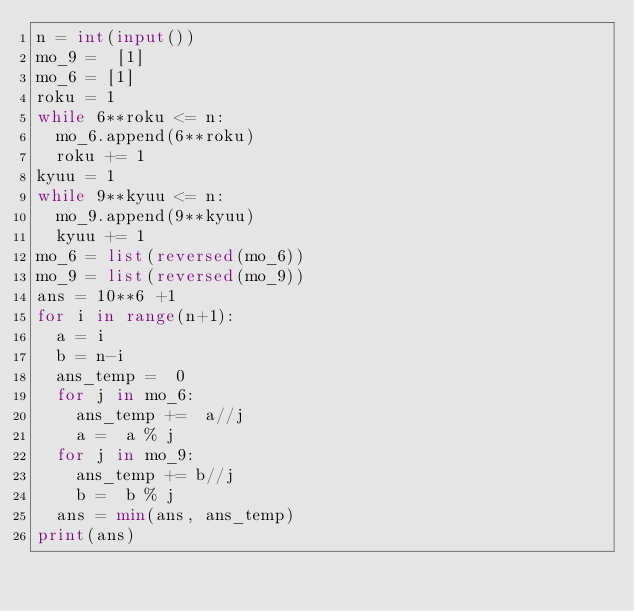Convert code to text. <code><loc_0><loc_0><loc_500><loc_500><_Python_>n = int(input())
mo_9 =  [1]
mo_6 = [1]
roku = 1
while 6**roku <= n:
  mo_6.append(6**roku)
  roku += 1
kyuu = 1
while 9**kyuu <= n:
  mo_9.append(9**kyuu)
  kyuu += 1
mo_6 = list(reversed(mo_6))
mo_9 = list(reversed(mo_9))
ans = 10**6 +1
for i in range(n+1):
  a = i
  b = n-i
  ans_temp =  0
  for j in mo_6:
    ans_temp +=  a//j
    a =  a % j
  for j in mo_9:
    ans_temp += b//j
    b =  b % j
  ans = min(ans, ans_temp)
print(ans)</code> 